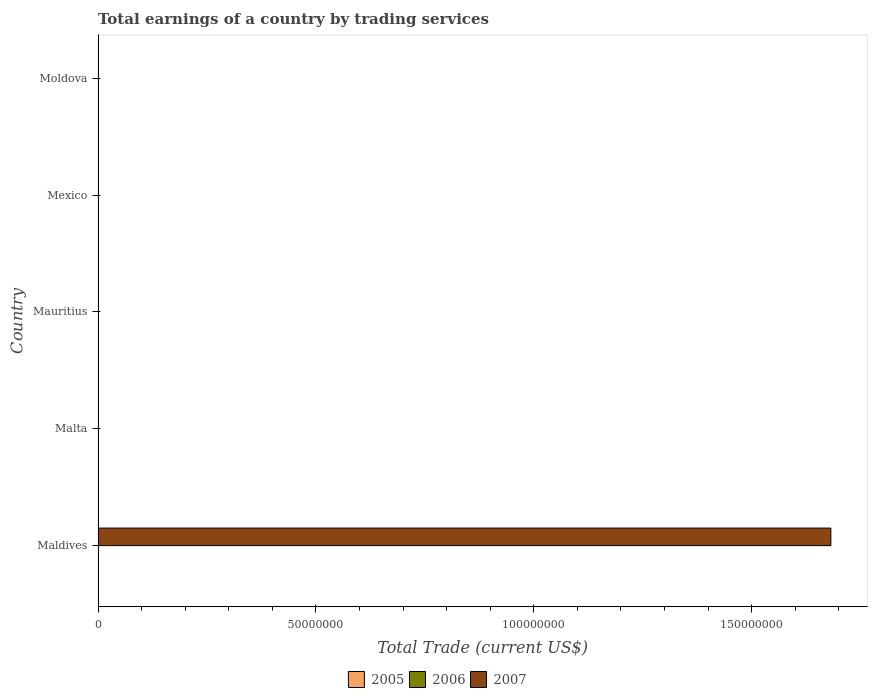How many different coloured bars are there?
Keep it short and to the point. 1. Are the number of bars on each tick of the Y-axis equal?
Offer a terse response. No. How many bars are there on the 2nd tick from the top?
Provide a short and direct response. 0. How many bars are there on the 4th tick from the bottom?
Offer a very short reply. 0. What is the label of the 5th group of bars from the top?
Your answer should be very brief. Maldives. What is the total earnings in 2005 in Mauritius?
Provide a succinct answer. 0. Across all countries, what is the maximum total earnings in 2007?
Provide a succinct answer. 1.68e+08. Across all countries, what is the minimum total earnings in 2007?
Offer a very short reply. 0. In which country was the total earnings in 2007 maximum?
Give a very brief answer. Maldives. What is the total total earnings in 2007 in the graph?
Ensure brevity in your answer.  1.68e+08. What is the average total earnings in 2006 per country?
Offer a very short reply. 0. In how many countries, is the total earnings in 2007 greater than 140000000 US$?
Keep it short and to the point. 1. What is the difference between the highest and the lowest total earnings in 2007?
Provide a short and direct response. 1.68e+08. In how many countries, is the total earnings in 2006 greater than the average total earnings in 2006 taken over all countries?
Your answer should be very brief. 0. How many bars are there?
Make the answer very short. 1. How many countries are there in the graph?
Your response must be concise. 5. What is the difference between two consecutive major ticks on the X-axis?
Give a very brief answer. 5.00e+07. How many legend labels are there?
Give a very brief answer. 3. How are the legend labels stacked?
Offer a very short reply. Horizontal. What is the title of the graph?
Provide a short and direct response. Total earnings of a country by trading services. Does "1978" appear as one of the legend labels in the graph?
Provide a short and direct response. No. What is the label or title of the X-axis?
Give a very brief answer. Total Trade (current US$). What is the label or title of the Y-axis?
Offer a very short reply. Country. What is the Total Trade (current US$) in 2007 in Maldives?
Your answer should be very brief. 1.68e+08. What is the Total Trade (current US$) of 2005 in Malta?
Keep it short and to the point. 0. What is the Total Trade (current US$) of 2006 in Malta?
Ensure brevity in your answer.  0. What is the Total Trade (current US$) of 2006 in Mauritius?
Ensure brevity in your answer.  0. What is the Total Trade (current US$) of 2007 in Mauritius?
Your answer should be very brief. 0. What is the Total Trade (current US$) of 2006 in Mexico?
Your response must be concise. 0. What is the Total Trade (current US$) in 2007 in Mexico?
Provide a succinct answer. 0. Across all countries, what is the maximum Total Trade (current US$) in 2007?
Provide a succinct answer. 1.68e+08. What is the total Total Trade (current US$) of 2005 in the graph?
Keep it short and to the point. 0. What is the total Total Trade (current US$) of 2007 in the graph?
Ensure brevity in your answer.  1.68e+08. What is the average Total Trade (current US$) in 2007 per country?
Make the answer very short. 3.36e+07. What is the difference between the highest and the lowest Total Trade (current US$) in 2007?
Provide a succinct answer. 1.68e+08. 